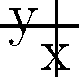In the context of Orwell's "1984," consider the heat map above representing the spread of propaganda in Oceania. The intensity of color indicates the concentration of propaganda, with red being the highest. If the epicenter (2,2) represents the Ministry of Truth, and the arrow indicates the direction of most effective propaganda dissemination, what function best describes the spread of propaganda from the epicenter? To answer this question, we need to analyze the heat map and relate it to the spread of propaganda as described in Orwell's "1984":

1. The heat map shows a circular pattern radiating from the epicenter (2,2), which represents the Ministry of Truth.

2. The intensity of the propaganda (represented by color) decreases as we move away from the epicenter in all directions.

3. This pattern suggests an exponential decay function, where the intensity is highest at the source and decreases rapidly as we move away.

4. The circular symmetry indicates that the decay is based on the distance from the epicenter in all directions.

5. In mathematical terms, this can be represented by a two-dimensional Gaussian function:

   $$f(x,y) = A \cdot e^{-\frac{(x-x_0)^2 + (y-y_0)^2}{2\sigma^2}}$$

   Where:
   - $A$ is the amplitude (maximum intensity at the epicenter)
   - $(x_0, y_0)$ is the center point (2,2 in this case)
   - $\sigma$ is the standard deviation, which controls the spread

6. The arrow indicating the direction of most effective propaganda dissemination suggests a slight asymmetry, but this is a minor factor compared to the overall circular spread.

Given these observations, the Gaussian function best describes the spread of propaganda from the epicenter, as it captures the exponential decay and circular symmetry seen in the heat map.
Answer: Gaussian function: $f(x,y) = A \cdot e^{-\frac{(x-2)^2 + (y-2)^2}{2\sigma^2}}$ 